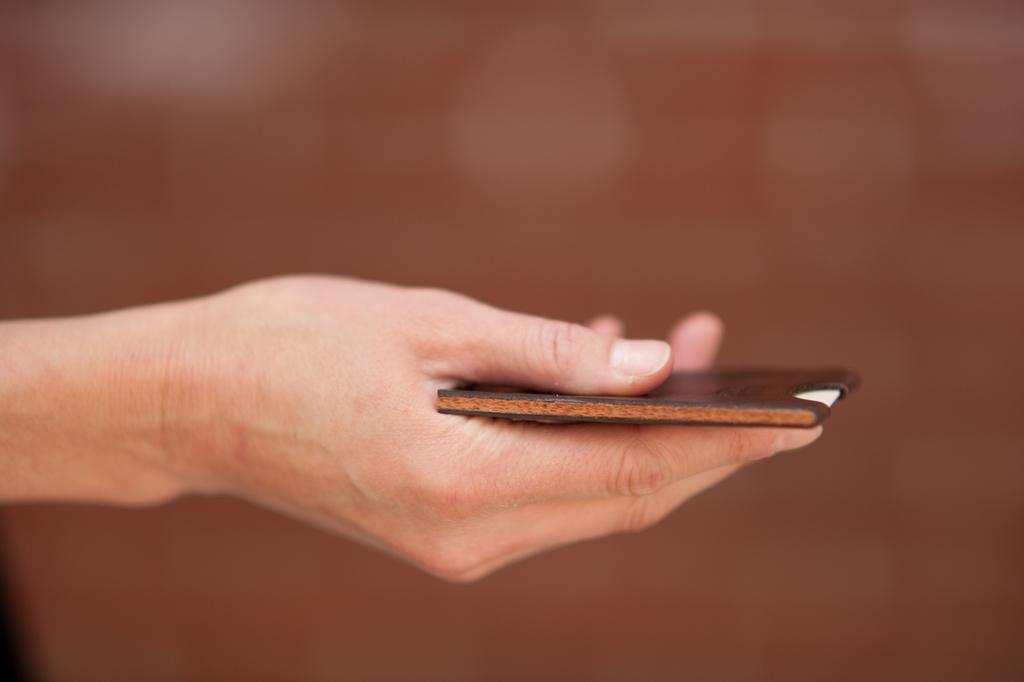What is being held by the hand in the image? The hand is holding a card. Where is the card located in relation to the image? The card is in the center of the image. Can you describe the position of the hand in the image? The hand is holding the card, but the specific position of the hand cannot be determined from the provided facts. What type of pie is being served in the image? There is no pie present in the image; it features a hand holding a card. 